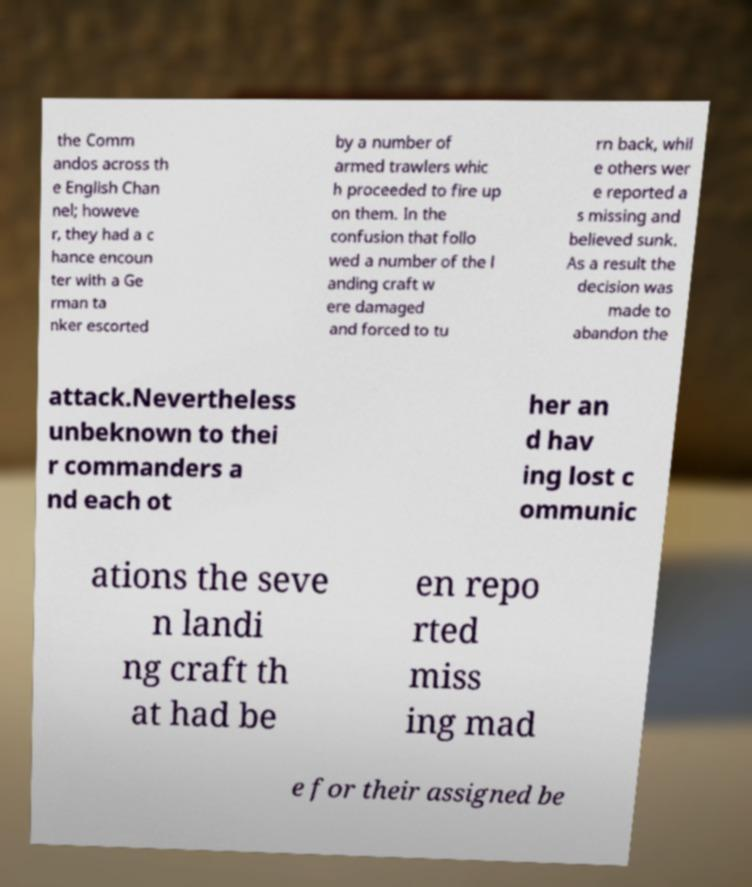I need the written content from this picture converted into text. Can you do that? the Comm andos across th e English Chan nel; howeve r, they had a c hance encoun ter with a Ge rman ta nker escorted by a number of armed trawlers whic h proceeded to fire up on them. In the confusion that follo wed a number of the l anding craft w ere damaged and forced to tu rn back, whil e others wer e reported a s missing and believed sunk. As a result the decision was made to abandon the attack.Nevertheless unbeknown to thei r commanders a nd each ot her an d hav ing lost c ommunic ations the seve n landi ng craft th at had be en repo rted miss ing mad e for their assigned be 